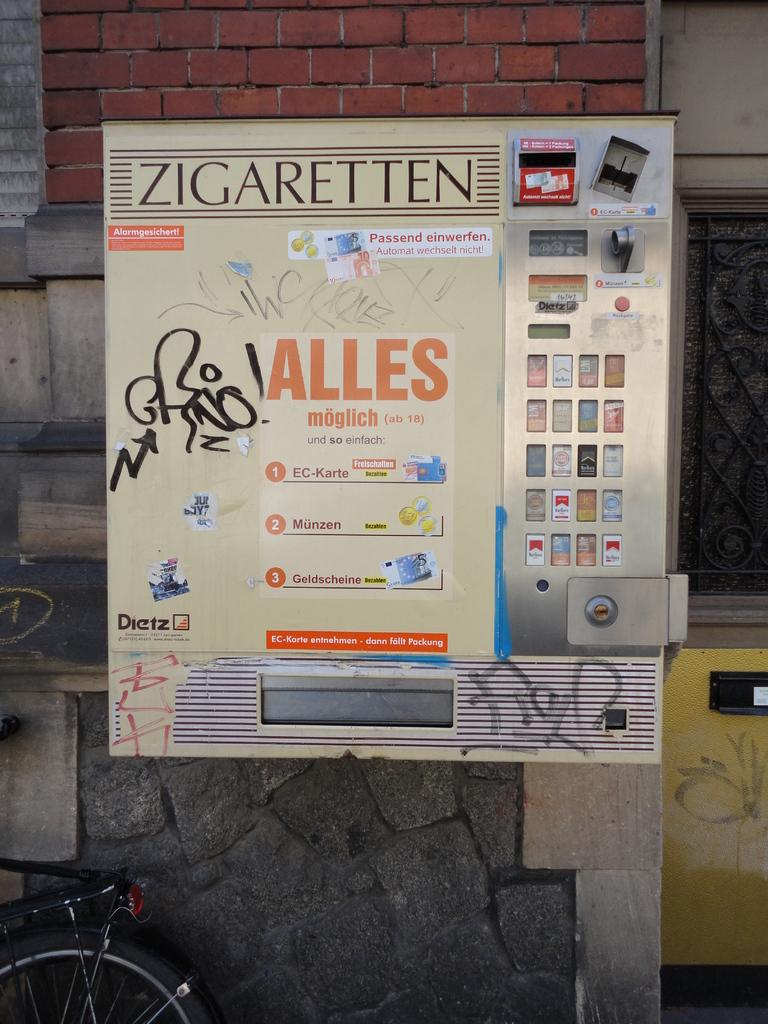What products is being sold in this machine?
Your answer should be compact. Zigaretten. 